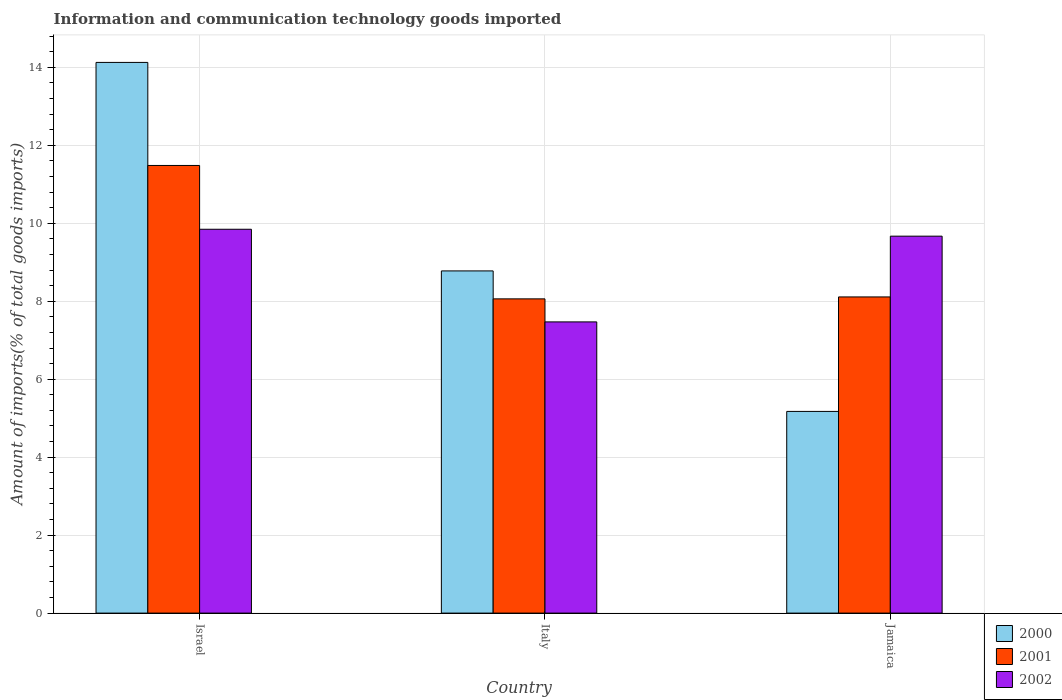How many different coloured bars are there?
Your response must be concise. 3. Are the number of bars per tick equal to the number of legend labels?
Provide a succinct answer. Yes. Are the number of bars on each tick of the X-axis equal?
Keep it short and to the point. Yes. How many bars are there on the 3rd tick from the right?
Give a very brief answer. 3. What is the label of the 2nd group of bars from the left?
Offer a terse response. Italy. In how many cases, is the number of bars for a given country not equal to the number of legend labels?
Keep it short and to the point. 0. What is the amount of goods imported in 2000 in Jamaica?
Offer a terse response. 5.17. Across all countries, what is the maximum amount of goods imported in 2002?
Your answer should be very brief. 9.85. Across all countries, what is the minimum amount of goods imported in 2001?
Provide a succinct answer. 8.06. In which country was the amount of goods imported in 2002 maximum?
Keep it short and to the point. Israel. In which country was the amount of goods imported in 2000 minimum?
Offer a terse response. Jamaica. What is the total amount of goods imported in 2000 in the graph?
Provide a succinct answer. 28.08. What is the difference between the amount of goods imported in 2000 in Israel and that in Jamaica?
Give a very brief answer. 8.95. What is the difference between the amount of goods imported in 2001 in Jamaica and the amount of goods imported in 2002 in Israel?
Keep it short and to the point. -1.74. What is the average amount of goods imported in 2000 per country?
Ensure brevity in your answer.  9.36. What is the difference between the amount of goods imported of/in 2001 and amount of goods imported of/in 2000 in Italy?
Provide a succinct answer. -0.72. In how many countries, is the amount of goods imported in 2000 greater than 2 %?
Offer a very short reply. 3. What is the ratio of the amount of goods imported in 2000 in Italy to that in Jamaica?
Provide a succinct answer. 1.7. Is the amount of goods imported in 2002 in Italy less than that in Jamaica?
Keep it short and to the point. Yes. What is the difference between the highest and the second highest amount of goods imported in 2001?
Ensure brevity in your answer.  0.05. What is the difference between the highest and the lowest amount of goods imported in 2001?
Provide a succinct answer. 3.42. In how many countries, is the amount of goods imported in 2001 greater than the average amount of goods imported in 2001 taken over all countries?
Your answer should be compact. 1. What does the 3rd bar from the left in Jamaica represents?
Your answer should be compact. 2002. Is it the case that in every country, the sum of the amount of goods imported in 2001 and amount of goods imported in 2000 is greater than the amount of goods imported in 2002?
Your answer should be very brief. Yes. Are all the bars in the graph horizontal?
Your answer should be very brief. No. What is the difference between two consecutive major ticks on the Y-axis?
Keep it short and to the point. 2. Are the values on the major ticks of Y-axis written in scientific E-notation?
Offer a very short reply. No. Does the graph contain any zero values?
Make the answer very short. No. Does the graph contain grids?
Provide a succinct answer. Yes. How many legend labels are there?
Make the answer very short. 3. What is the title of the graph?
Make the answer very short. Information and communication technology goods imported. Does "1986" appear as one of the legend labels in the graph?
Provide a succinct answer. No. What is the label or title of the Y-axis?
Keep it short and to the point. Amount of imports(% of total goods imports). What is the Amount of imports(% of total goods imports) in 2000 in Israel?
Keep it short and to the point. 14.13. What is the Amount of imports(% of total goods imports) in 2001 in Israel?
Ensure brevity in your answer.  11.48. What is the Amount of imports(% of total goods imports) of 2002 in Israel?
Provide a short and direct response. 9.85. What is the Amount of imports(% of total goods imports) of 2000 in Italy?
Your response must be concise. 8.78. What is the Amount of imports(% of total goods imports) in 2001 in Italy?
Your response must be concise. 8.06. What is the Amount of imports(% of total goods imports) of 2002 in Italy?
Your response must be concise. 7.47. What is the Amount of imports(% of total goods imports) of 2000 in Jamaica?
Give a very brief answer. 5.17. What is the Amount of imports(% of total goods imports) in 2001 in Jamaica?
Give a very brief answer. 8.11. What is the Amount of imports(% of total goods imports) in 2002 in Jamaica?
Your answer should be very brief. 9.67. Across all countries, what is the maximum Amount of imports(% of total goods imports) in 2000?
Make the answer very short. 14.13. Across all countries, what is the maximum Amount of imports(% of total goods imports) in 2001?
Make the answer very short. 11.48. Across all countries, what is the maximum Amount of imports(% of total goods imports) of 2002?
Your answer should be compact. 9.85. Across all countries, what is the minimum Amount of imports(% of total goods imports) in 2000?
Give a very brief answer. 5.17. Across all countries, what is the minimum Amount of imports(% of total goods imports) in 2001?
Provide a succinct answer. 8.06. Across all countries, what is the minimum Amount of imports(% of total goods imports) in 2002?
Your response must be concise. 7.47. What is the total Amount of imports(% of total goods imports) in 2000 in the graph?
Offer a terse response. 28.08. What is the total Amount of imports(% of total goods imports) in 2001 in the graph?
Offer a terse response. 27.66. What is the total Amount of imports(% of total goods imports) of 2002 in the graph?
Give a very brief answer. 26.99. What is the difference between the Amount of imports(% of total goods imports) in 2000 in Israel and that in Italy?
Offer a terse response. 5.35. What is the difference between the Amount of imports(% of total goods imports) of 2001 in Israel and that in Italy?
Offer a very short reply. 3.42. What is the difference between the Amount of imports(% of total goods imports) in 2002 in Israel and that in Italy?
Your answer should be compact. 2.38. What is the difference between the Amount of imports(% of total goods imports) in 2000 in Israel and that in Jamaica?
Offer a terse response. 8.95. What is the difference between the Amount of imports(% of total goods imports) of 2001 in Israel and that in Jamaica?
Provide a succinct answer. 3.37. What is the difference between the Amount of imports(% of total goods imports) of 2002 in Israel and that in Jamaica?
Your response must be concise. 0.18. What is the difference between the Amount of imports(% of total goods imports) in 2000 in Italy and that in Jamaica?
Offer a terse response. 3.6. What is the difference between the Amount of imports(% of total goods imports) in 2001 in Italy and that in Jamaica?
Provide a succinct answer. -0.05. What is the difference between the Amount of imports(% of total goods imports) in 2002 in Italy and that in Jamaica?
Offer a very short reply. -2.2. What is the difference between the Amount of imports(% of total goods imports) of 2000 in Israel and the Amount of imports(% of total goods imports) of 2001 in Italy?
Make the answer very short. 6.07. What is the difference between the Amount of imports(% of total goods imports) in 2000 in Israel and the Amount of imports(% of total goods imports) in 2002 in Italy?
Keep it short and to the point. 6.66. What is the difference between the Amount of imports(% of total goods imports) in 2001 in Israel and the Amount of imports(% of total goods imports) in 2002 in Italy?
Offer a very short reply. 4.01. What is the difference between the Amount of imports(% of total goods imports) in 2000 in Israel and the Amount of imports(% of total goods imports) in 2001 in Jamaica?
Ensure brevity in your answer.  6.02. What is the difference between the Amount of imports(% of total goods imports) in 2000 in Israel and the Amount of imports(% of total goods imports) in 2002 in Jamaica?
Provide a short and direct response. 4.46. What is the difference between the Amount of imports(% of total goods imports) of 2001 in Israel and the Amount of imports(% of total goods imports) of 2002 in Jamaica?
Give a very brief answer. 1.81. What is the difference between the Amount of imports(% of total goods imports) of 2000 in Italy and the Amount of imports(% of total goods imports) of 2001 in Jamaica?
Your response must be concise. 0.67. What is the difference between the Amount of imports(% of total goods imports) in 2000 in Italy and the Amount of imports(% of total goods imports) in 2002 in Jamaica?
Your answer should be compact. -0.89. What is the difference between the Amount of imports(% of total goods imports) of 2001 in Italy and the Amount of imports(% of total goods imports) of 2002 in Jamaica?
Give a very brief answer. -1.61. What is the average Amount of imports(% of total goods imports) in 2000 per country?
Give a very brief answer. 9.36. What is the average Amount of imports(% of total goods imports) of 2001 per country?
Provide a short and direct response. 9.22. What is the average Amount of imports(% of total goods imports) in 2002 per country?
Your response must be concise. 9. What is the difference between the Amount of imports(% of total goods imports) of 2000 and Amount of imports(% of total goods imports) of 2001 in Israel?
Make the answer very short. 2.64. What is the difference between the Amount of imports(% of total goods imports) of 2000 and Amount of imports(% of total goods imports) of 2002 in Israel?
Your answer should be very brief. 4.28. What is the difference between the Amount of imports(% of total goods imports) of 2001 and Amount of imports(% of total goods imports) of 2002 in Israel?
Your response must be concise. 1.64. What is the difference between the Amount of imports(% of total goods imports) in 2000 and Amount of imports(% of total goods imports) in 2001 in Italy?
Provide a short and direct response. 0.72. What is the difference between the Amount of imports(% of total goods imports) in 2000 and Amount of imports(% of total goods imports) in 2002 in Italy?
Your response must be concise. 1.31. What is the difference between the Amount of imports(% of total goods imports) in 2001 and Amount of imports(% of total goods imports) in 2002 in Italy?
Your answer should be compact. 0.59. What is the difference between the Amount of imports(% of total goods imports) of 2000 and Amount of imports(% of total goods imports) of 2001 in Jamaica?
Your response must be concise. -2.94. What is the difference between the Amount of imports(% of total goods imports) in 2000 and Amount of imports(% of total goods imports) in 2002 in Jamaica?
Keep it short and to the point. -4.5. What is the difference between the Amount of imports(% of total goods imports) in 2001 and Amount of imports(% of total goods imports) in 2002 in Jamaica?
Provide a short and direct response. -1.56. What is the ratio of the Amount of imports(% of total goods imports) in 2000 in Israel to that in Italy?
Your answer should be compact. 1.61. What is the ratio of the Amount of imports(% of total goods imports) of 2001 in Israel to that in Italy?
Offer a very short reply. 1.42. What is the ratio of the Amount of imports(% of total goods imports) in 2002 in Israel to that in Italy?
Provide a succinct answer. 1.32. What is the ratio of the Amount of imports(% of total goods imports) of 2000 in Israel to that in Jamaica?
Your answer should be very brief. 2.73. What is the ratio of the Amount of imports(% of total goods imports) in 2001 in Israel to that in Jamaica?
Offer a terse response. 1.42. What is the ratio of the Amount of imports(% of total goods imports) of 2002 in Israel to that in Jamaica?
Your response must be concise. 1.02. What is the ratio of the Amount of imports(% of total goods imports) in 2000 in Italy to that in Jamaica?
Offer a very short reply. 1.7. What is the ratio of the Amount of imports(% of total goods imports) in 2001 in Italy to that in Jamaica?
Offer a terse response. 0.99. What is the ratio of the Amount of imports(% of total goods imports) in 2002 in Italy to that in Jamaica?
Provide a succinct answer. 0.77. What is the difference between the highest and the second highest Amount of imports(% of total goods imports) of 2000?
Give a very brief answer. 5.35. What is the difference between the highest and the second highest Amount of imports(% of total goods imports) in 2001?
Your answer should be compact. 3.37. What is the difference between the highest and the second highest Amount of imports(% of total goods imports) in 2002?
Your response must be concise. 0.18. What is the difference between the highest and the lowest Amount of imports(% of total goods imports) in 2000?
Ensure brevity in your answer.  8.95. What is the difference between the highest and the lowest Amount of imports(% of total goods imports) of 2001?
Your response must be concise. 3.42. What is the difference between the highest and the lowest Amount of imports(% of total goods imports) in 2002?
Offer a very short reply. 2.38. 